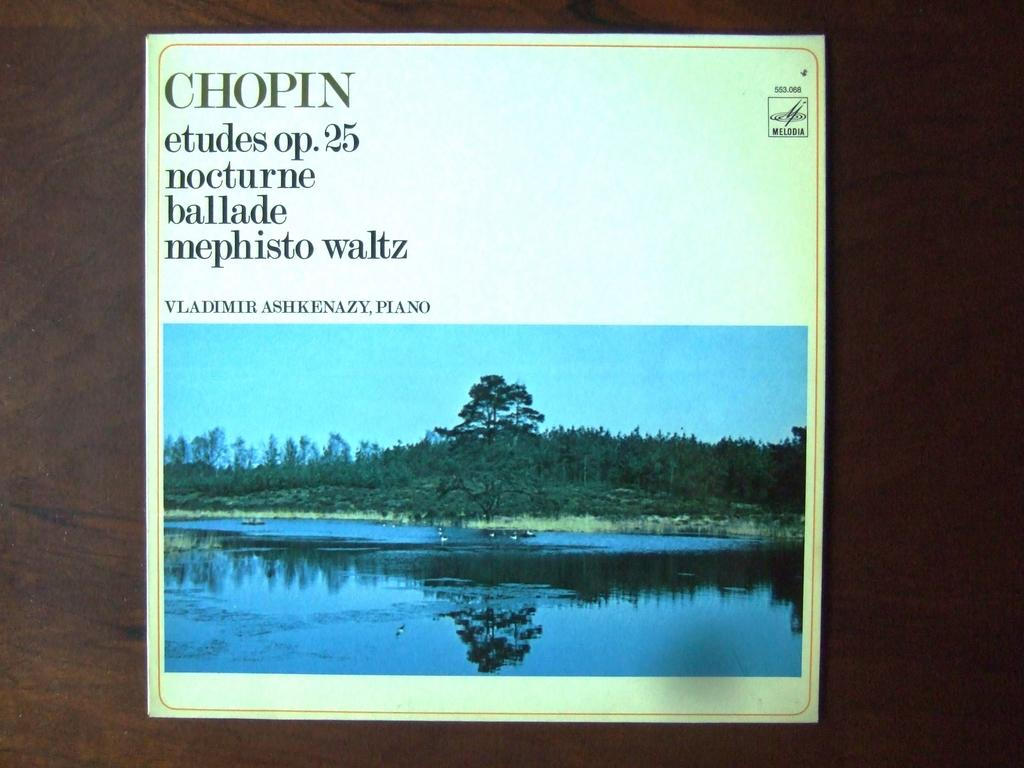What is the main subject of the wall painting in the image? The wall painting depicts water, birds, trees, and the sky. Can you describe the elements depicted in the wall painting? The wall painting depicts water, birds, trees, and the sky. What is the overall theme or setting of the wall painting? The wall painting depicts a natural scene, featuring water, birds, trees, and the sky. What type of coat is hanging on the tree in the wall painting? There is no coat present in the wall painting; it depicts a natural scene with water, birds, trees, and the sky. 